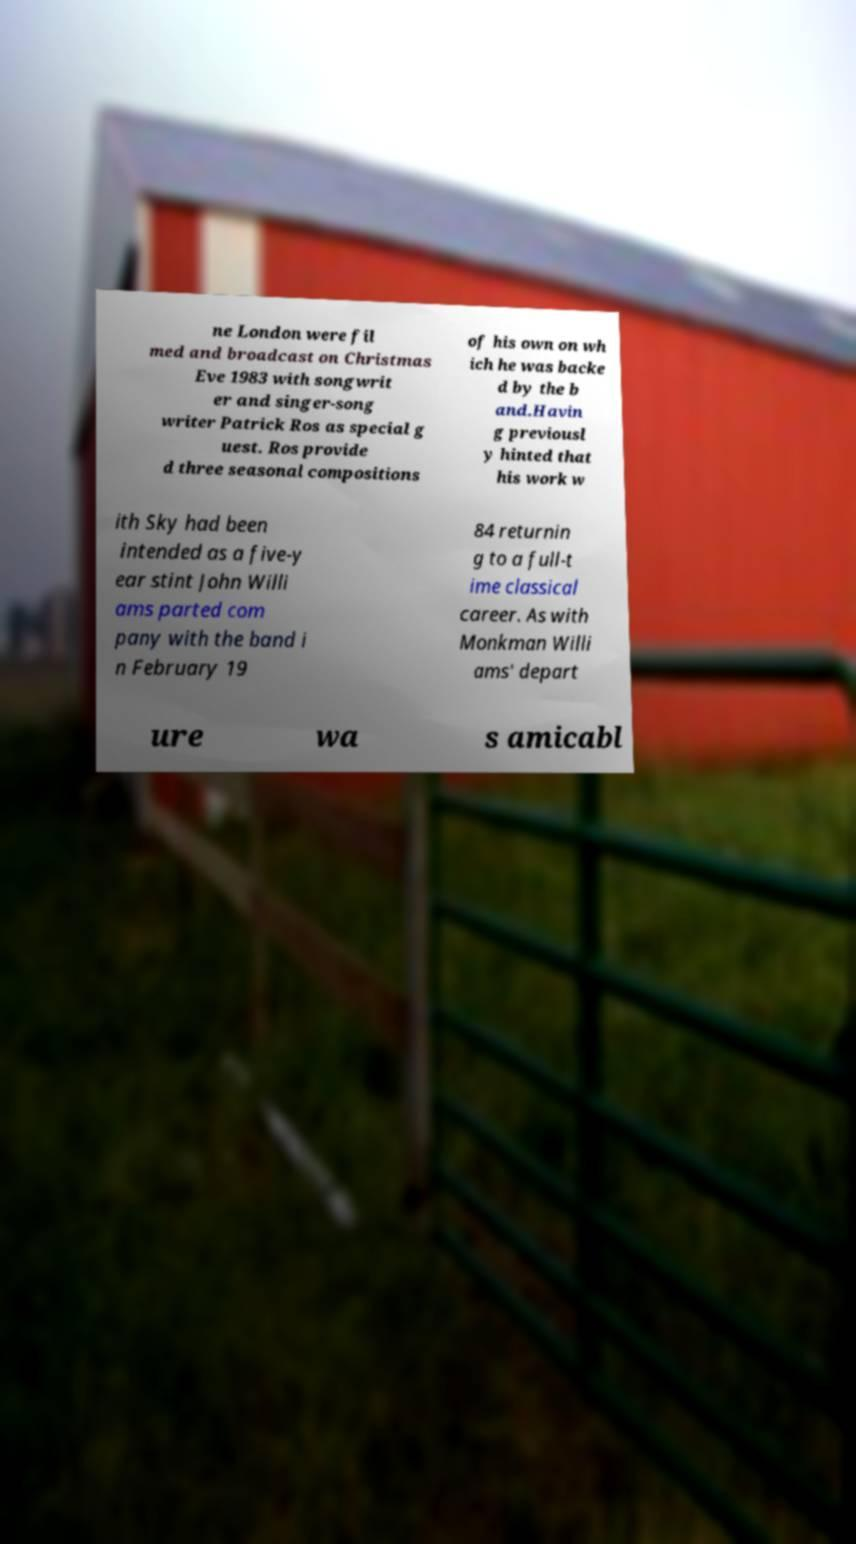Can you accurately transcribe the text from the provided image for me? ne London were fil med and broadcast on Christmas Eve 1983 with songwrit er and singer-song writer Patrick Ros as special g uest. Ros provide d three seasonal compositions of his own on wh ich he was backe d by the b and.Havin g previousl y hinted that his work w ith Sky had been intended as a five-y ear stint John Willi ams parted com pany with the band i n February 19 84 returnin g to a full-t ime classical career. As with Monkman Willi ams' depart ure wa s amicabl 